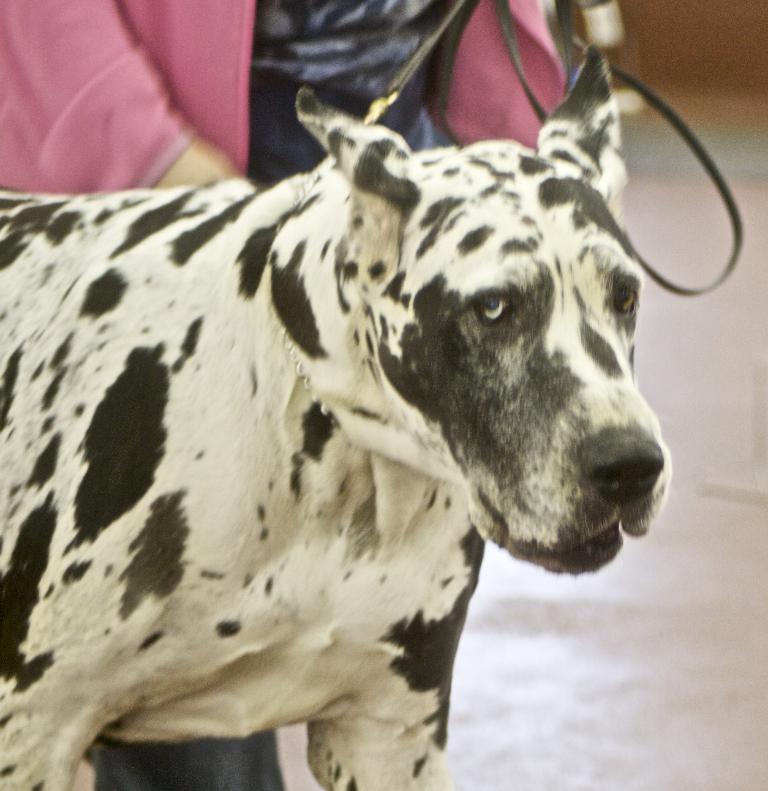Could you give a brief overview of what you see in this image? In this picture we can see a person and a dog on the path. 